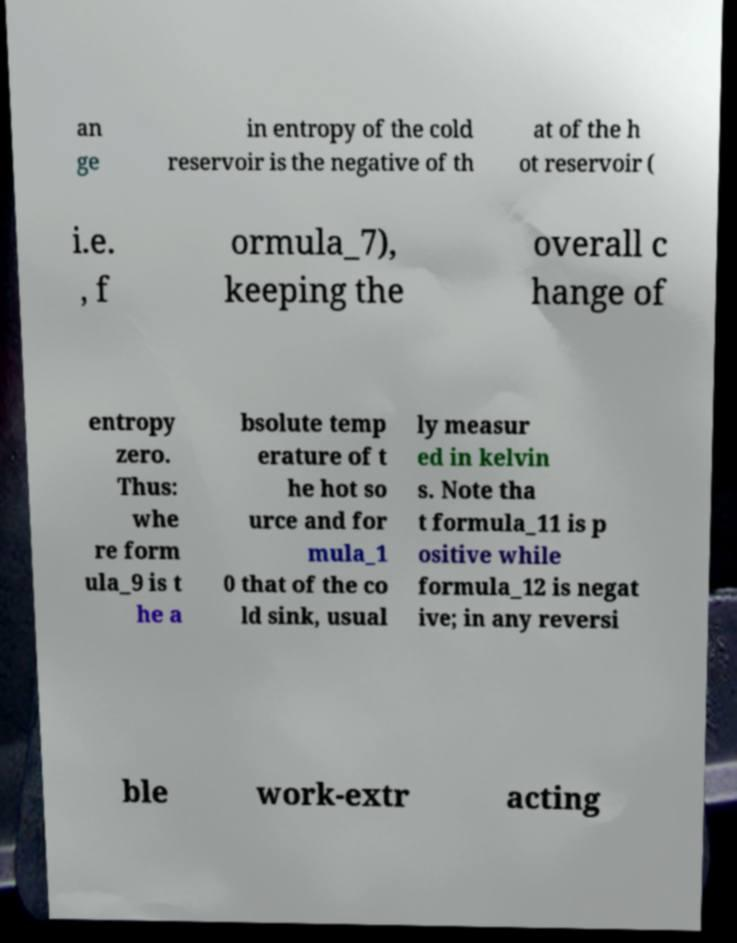Can you accurately transcribe the text from the provided image for me? an ge in entropy of the cold reservoir is the negative of th at of the h ot reservoir ( i.e. , f ormula_7), keeping the overall c hange of entropy zero. Thus: whe re form ula_9 is t he a bsolute temp erature of t he hot so urce and for mula_1 0 that of the co ld sink, usual ly measur ed in kelvin s. Note tha t formula_11 is p ositive while formula_12 is negat ive; in any reversi ble work-extr acting 